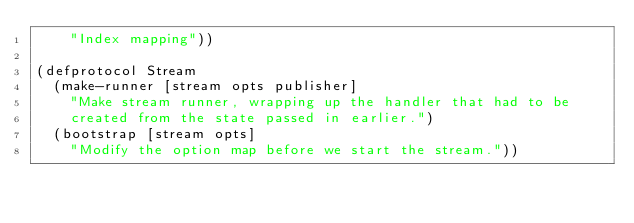Convert code to text. <code><loc_0><loc_0><loc_500><loc_500><_Clojure_>    "Index mapping"))

(defprotocol Stream
  (make-runner [stream opts publisher]
    "Make stream runner, wrapping up the handler that had to be
    created from the state passed in earlier.")
  (bootstrap [stream opts]
    "Modify the option map before we start the stream."))
</code> 